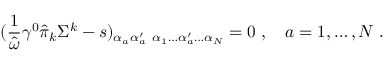<formula> <loc_0><loc_0><loc_500><loc_500>( { \frac { 1 } { \hat { \omega } } } \gamma ^ { 0 } \hat { \pi } _ { k } \Sigma ^ { k } - s ) _ { \alpha _ { a } \alpha _ { a } ^ { \prime } } { \Psi } _ { \alpha _ { 1 } \dots \alpha _ { a } ^ { \prime } \dots \alpha _ { N } } = 0 \, , \quad a = 1 , \dots , N \, .</formula> 